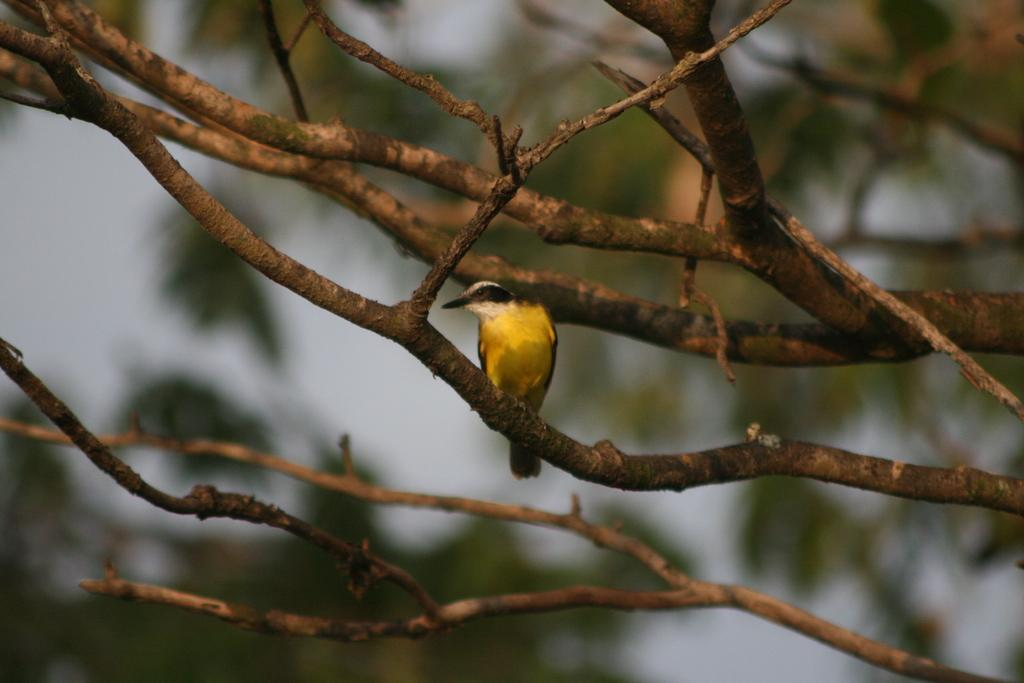What can be seen in the image besides the branches? There is a bird on one of the branches. How is the background of the image depicted? The background of the image is blurred. What direction is the frog facing in the image? There is no frog present in the image. What type of war is depicted in the image? There is no war depicted in the image; it features branches and a bird. 